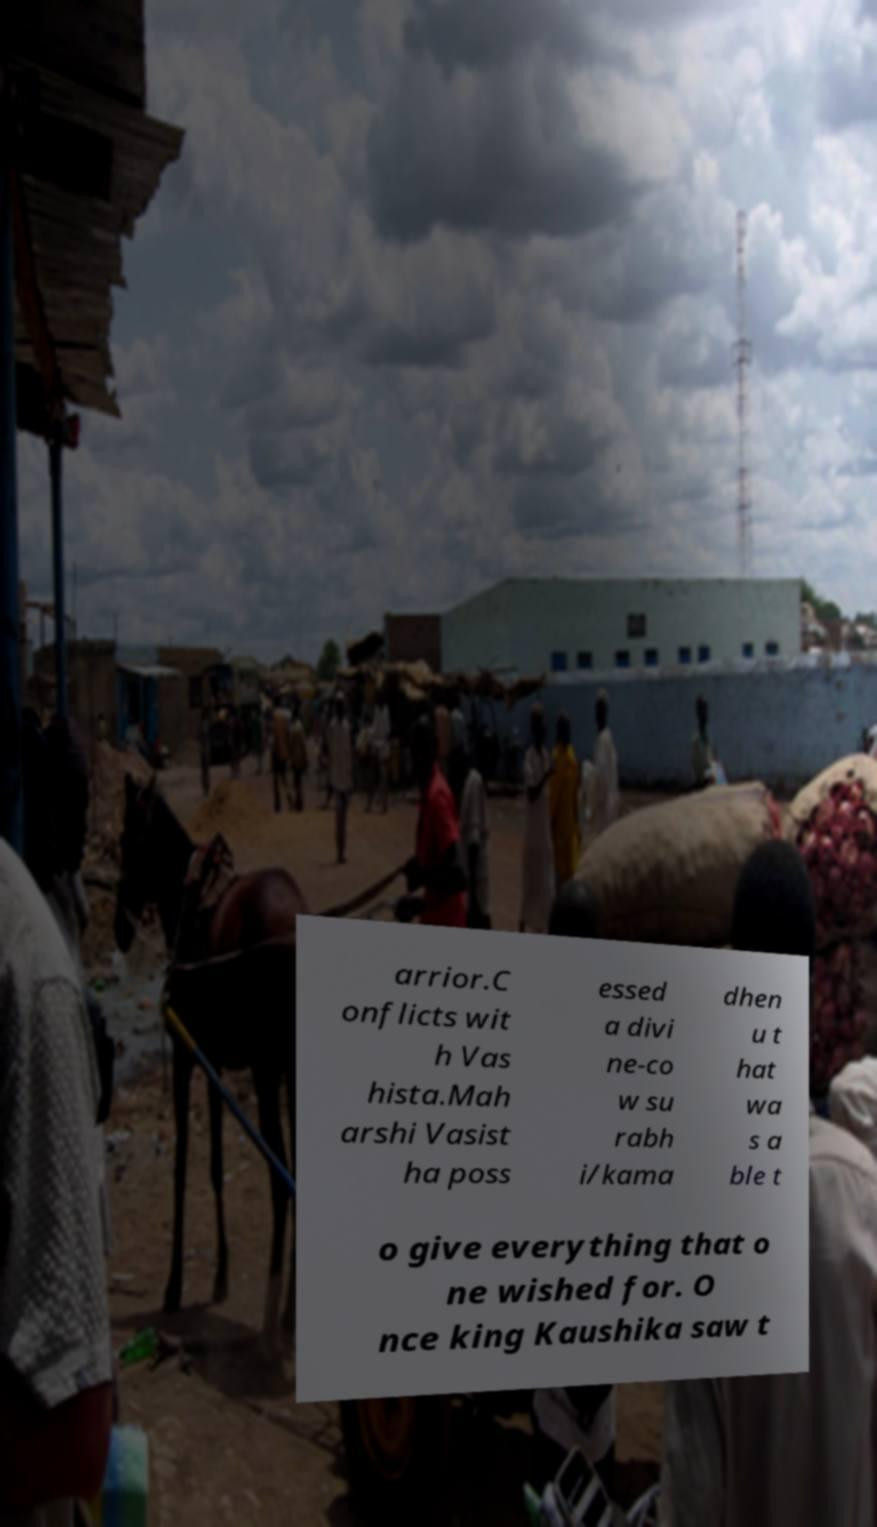Could you extract and type out the text from this image? arrior.C onflicts wit h Vas hista.Mah arshi Vasist ha poss essed a divi ne-co w su rabh i/kama dhen u t hat wa s a ble t o give everything that o ne wished for. O nce king Kaushika saw t 